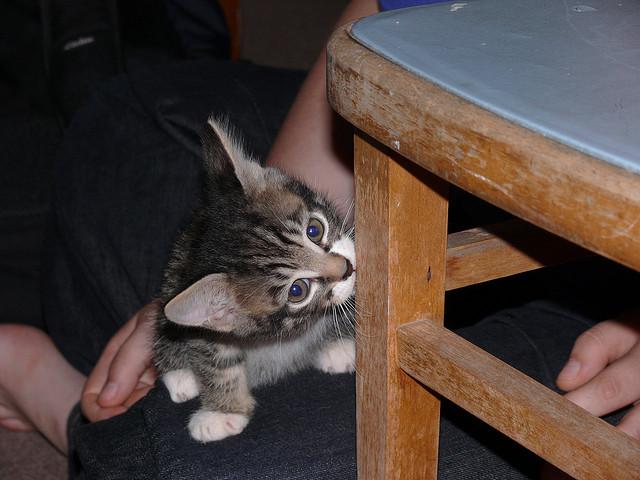Is the chair scratched?
Answer briefly. Yes. Is the cat on a person's lap?
Write a very short answer. Yes. Is this animal fully grown?
Keep it brief. No. 